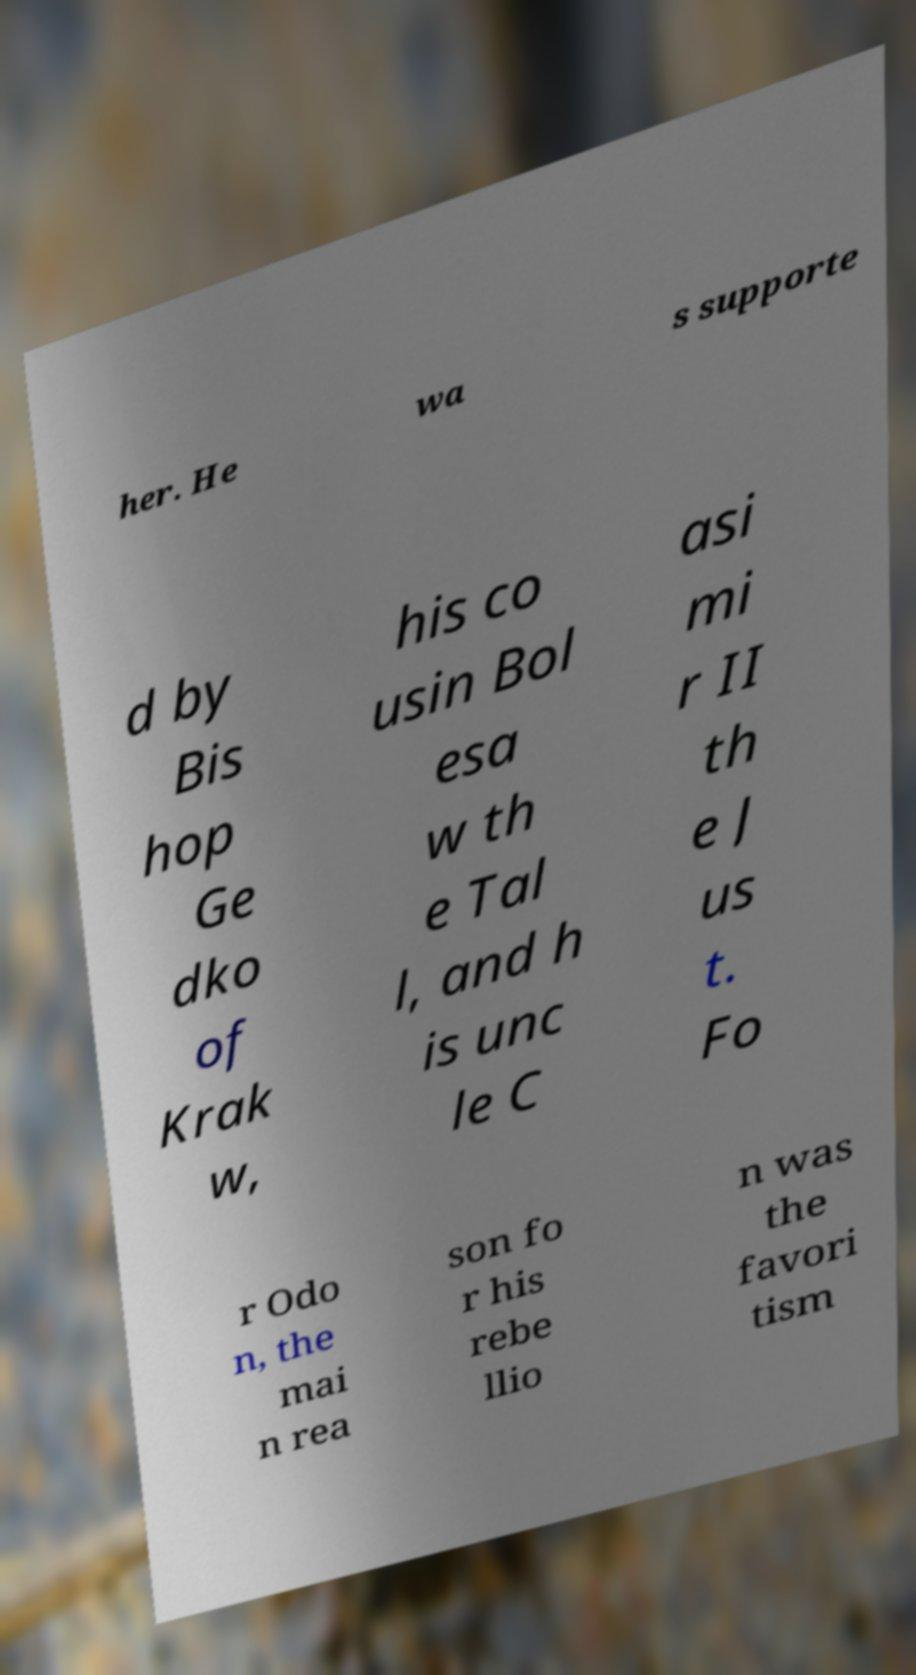Please read and relay the text visible in this image. What does it say? her. He wa s supporte d by Bis hop Ge dko of Krak w, his co usin Bol esa w th e Tal l, and h is unc le C asi mi r II th e J us t. Fo r Odo n, the mai n rea son fo r his rebe llio n was the favori tism 